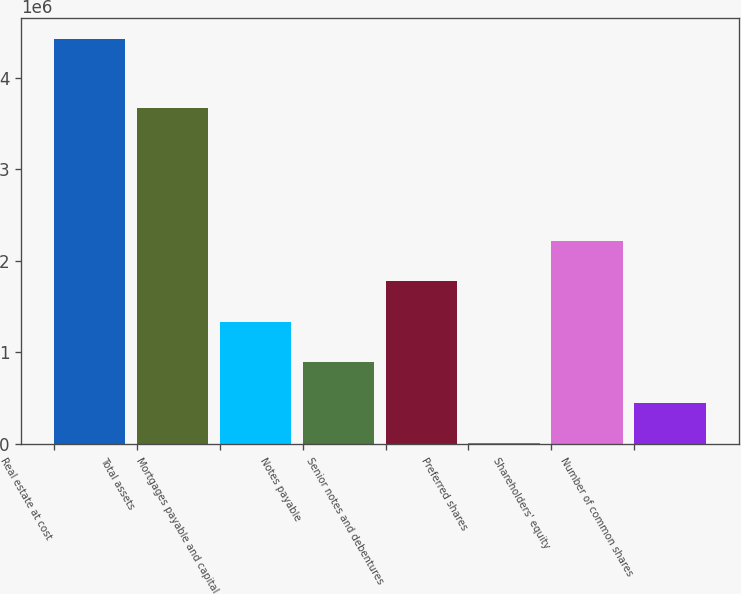<chart> <loc_0><loc_0><loc_500><loc_500><bar_chart><fcel>Real estate at cost<fcel>Total assets<fcel>Mortgages payable and capital<fcel>Notes payable<fcel>Senior notes and debentures<fcel>Preferred shares<fcel>Shareholders' equity<fcel>Number of common shares<nl><fcel>4.42644e+06<fcel>3.66621e+06<fcel>1.33493e+06<fcel>893286<fcel>1.77658e+06<fcel>9997<fcel>2.21822e+06<fcel>451642<nl></chart> 